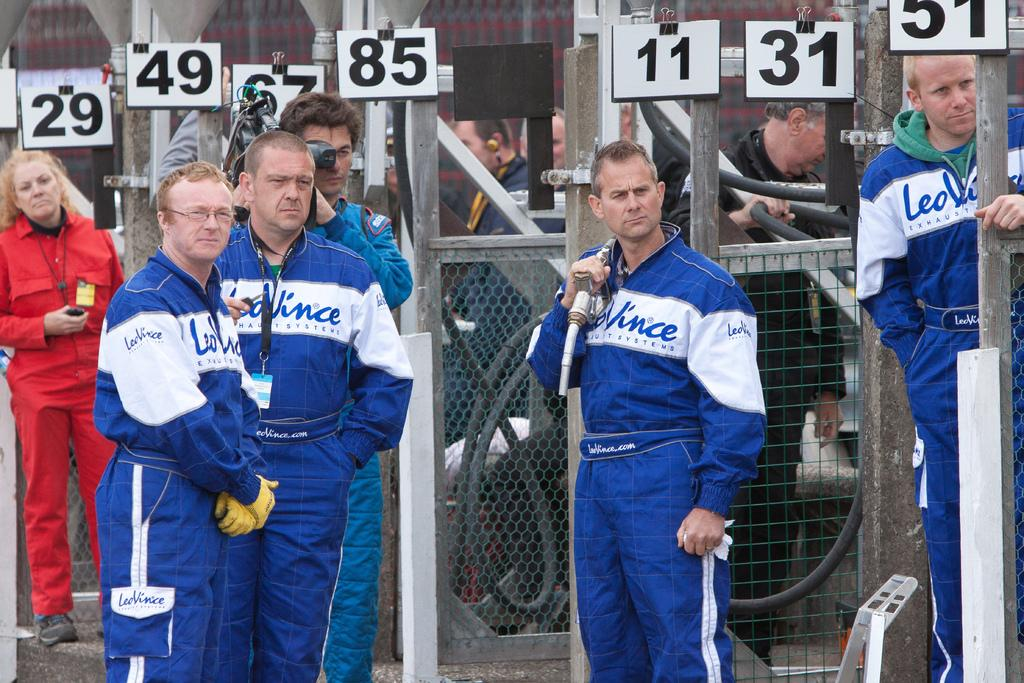<image>
Present a compact description of the photo's key features. A group of men wearing matching Leo Vinice jumpsuits stand waiting. 